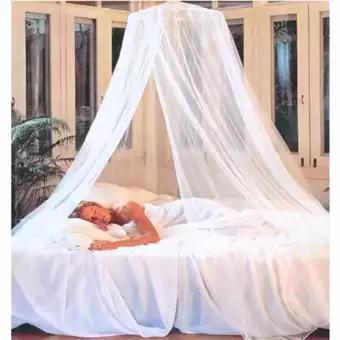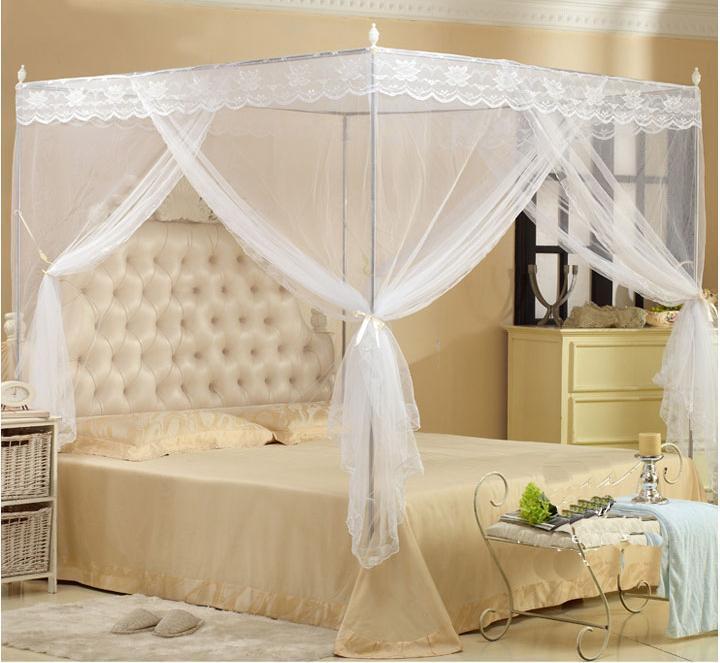The first image is the image on the left, the second image is the image on the right. Given the left and right images, does the statement "The right image shows a non-white canopy." hold true? Answer yes or no. No. The first image is the image on the left, the second image is the image on the right. Analyze the images presented: Is the assertion "The netting in the right image is white." valid? Answer yes or no. Yes. 